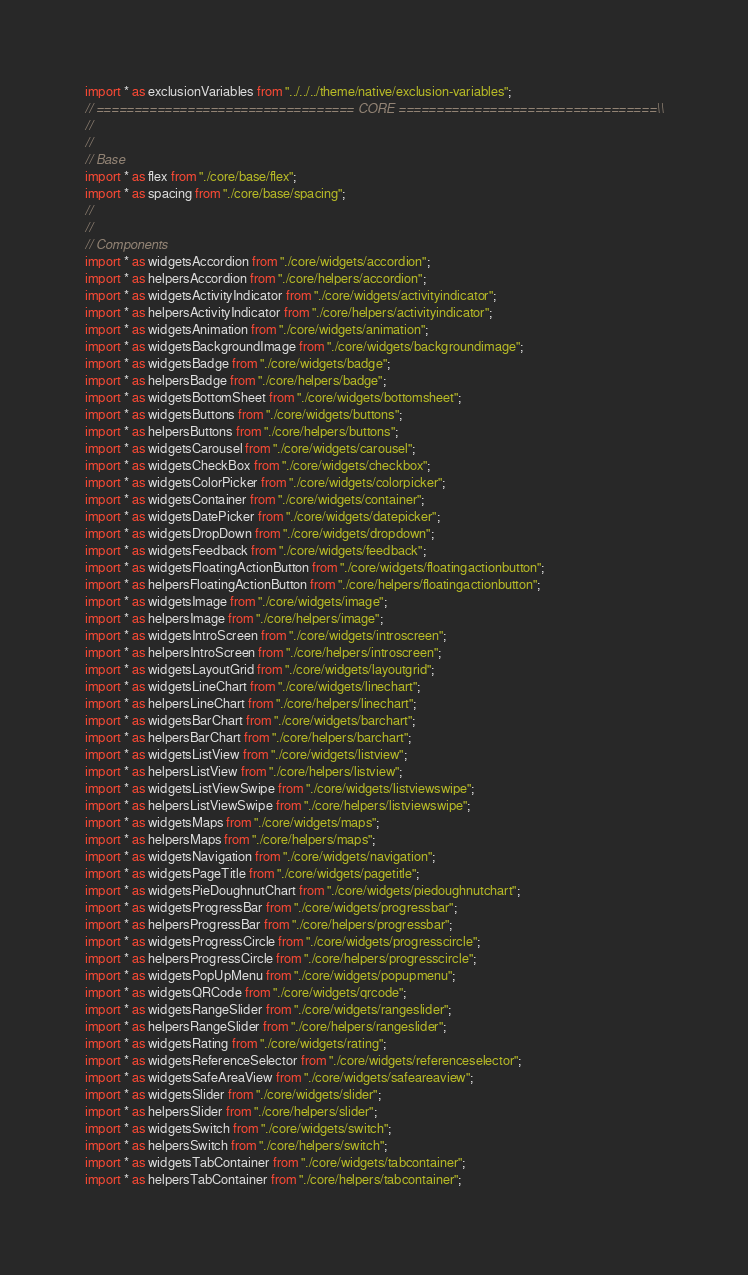<code> <loc_0><loc_0><loc_500><loc_500><_JavaScript_>import * as exclusionVariables from "../../../theme/native/exclusion-variables";
// ================================== CORE ==================================\\
//
//
// Base
import * as flex from "./core/base/flex";
import * as spacing from "./core/base/spacing";
//
//
// Components
import * as widgetsAccordion from "./core/widgets/accordion";
import * as helpersAccordion from "./core/helpers/accordion";
import * as widgetsActivityIndicator from "./core/widgets/activityindicator";
import * as helpersActivityIndicator from "./core/helpers/activityindicator";
import * as widgetsAnimation from "./core/widgets/animation";
import * as widgetsBackgroundImage from "./core/widgets/backgroundimage";
import * as widgetsBadge from "./core/widgets/badge";
import * as helpersBadge from "./core/helpers/badge";
import * as widgetsBottomSheet from "./core/widgets/bottomsheet";
import * as widgetsButtons from "./core/widgets/buttons";
import * as helpersButtons from "./core/helpers/buttons";
import * as widgetsCarousel from "./core/widgets/carousel";
import * as widgetsCheckBox from "./core/widgets/checkbox";
import * as widgetsColorPicker from "./core/widgets/colorpicker";
import * as widgetsContainer from "./core/widgets/container";
import * as widgetsDatePicker from "./core/widgets/datepicker";
import * as widgetsDropDown from "./core/widgets/dropdown";
import * as widgetsFeedback from "./core/widgets/feedback";
import * as widgetsFloatingActionButton from "./core/widgets/floatingactionbutton";
import * as helpersFloatingActionButton from "./core/helpers/floatingactionbutton";
import * as widgetsImage from "./core/widgets/image";
import * as helpersImage from "./core/helpers/image";
import * as widgetsIntroScreen from "./core/widgets/introscreen";
import * as helpersIntroScreen from "./core/helpers/introscreen";
import * as widgetsLayoutGrid from "./core/widgets/layoutgrid";
import * as widgetsLineChart from "./core/widgets/linechart";
import * as helpersLineChart from "./core/helpers/linechart";
import * as widgetsBarChart from "./core/widgets/barchart";
import * as helpersBarChart from "./core/helpers/barchart";
import * as widgetsListView from "./core/widgets/listview";
import * as helpersListView from "./core/helpers/listview";
import * as widgetsListViewSwipe from "./core/widgets/listviewswipe";
import * as helpersListViewSwipe from "./core/helpers/listviewswipe";
import * as widgetsMaps from "./core/widgets/maps";
import * as helpersMaps from "./core/helpers/maps";
import * as widgetsNavigation from "./core/widgets/navigation";
import * as widgetsPageTitle from "./core/widgets/pagetitle";
import * as widgetsPieDoughnutChart from "./core/widgets/piedoughnutchart";
import * as widgetsProgressBar from "./core/widgets/progressbar";
import * as helpersProgressBar from "./core/helpers/progressbar";
import * as widgetsProgressCircle from "./core/widgets/progresscircle";
import * as helpersProgressCircle from "./core/helpers/progresscircle";
import * as widgetsPopUpMenu from "./core/widgets/popupmenu";
import * as widgetsQRCode from "./core/widgets/qrcode";
import * as widgetsRangeSlider from "./core/widgets/rangeslider";
import * as helpersRangeSlider from "./core/helpers/rangeslider";
import * as widgetsRating from "./core/widgets/rating";
import * as widgetsReferenceSelector from "./core/widgets/referenceselector";
import * as widgetsSafeAreaView from "./core/widgets/safeareaview";
import * as widgetsSlider from "./core/widgets/slider";
import * as helpersSlider from "./core/helpers/slider";
import * as widgetsSwitch from "./core/widgets/switch";
import * as helpersSwitch from "./core/helpers/switch";
import * as widgetsTabContainer from "./core/widgets/tabcontainer";
import * as helpersTabContainer from "./core/helpers/tabcontainer";</code> 